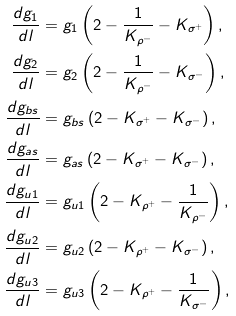Convert formula to latex. <formula><loc_0><loc_0><loc_500><loc_500>\frac { d g _ { 1 } } { d l } & = g _ { 1 } \left ( 2 - \frac { 1 } { K _ { \rho ^ { - } } } - K _ { \sigma ^ { + } } \right ) , \\ \frac { d g _ { 2 } } { d l } & = g _ { 2 } \left ( 2 - \frac { 1 } { K _ { \rho ^ { - } } } - K _ { \sigma ^ { - } } \right ) , \\ \frac { d g _ { b s } } { d l } & = g _ { b s } \left ( 2 - K _ { \sigma ^ { + } } - K _ { \sigma ^ { - } } \right ) , \\ \frac { d g _ { a s } } { d l } & = g _ { a s } \left ( 2 - K _ { \sigma ^ { + } } - K _ { \sigma ^ { - } } \right ) , \\ \frac { d g _ { u 1 } } { d l } & = g _ { u 1 } \left ( 2 - K _ { \rho ^ { + } } - \frac { 1 } { K _ { \rho ^ { - } } } \right ) , \\ \frac { d g _ { u 2 } } { d l } & = g _ { u 2 } \left ( 2 - K _ { \rho ^ { + } } - K _ { \sigma ^ { - } } \right ) , \\ \frac { d g _ { u 3 } } { d l } & = g _ { u 3 } \left ( 2 - K _ { \rho ^ { + } } - \frac { 1 } { K _ { \sigma ^ { - } } } \right ) ,</formula> 